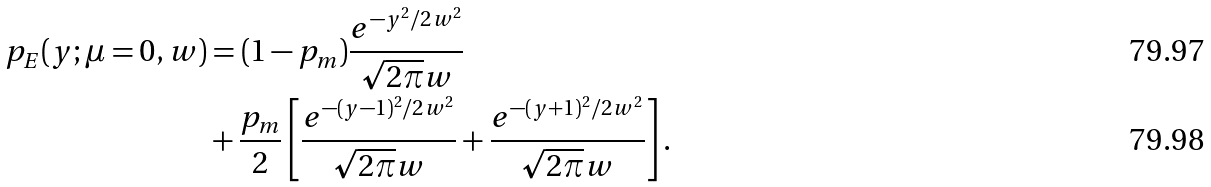<formula> <loc_0><loc_0><loc_500><loc_500>p _ { E } ( y ; \mu = 0 , w ) & = ( 1 - p _ { m } ) \frac { e ^ { - y ^ { 2 } / 2 w ^ { 2 } } } { \sqrt { 2 \pi } w } \\ & + \frac { p _ { m } } { 2 } \left [ \frac { e ^ { - ( y - 1 ) ^ { 2 } / 2 w ^ { 2 } } } { \sqrt { 2 \pi } w } + \frac { e ^ { - ( y + 1 ) ^ { 2 } / 2 w ^ { 2 } } } { \sqrt { 2 \pi } w } \right ] .</formula> 